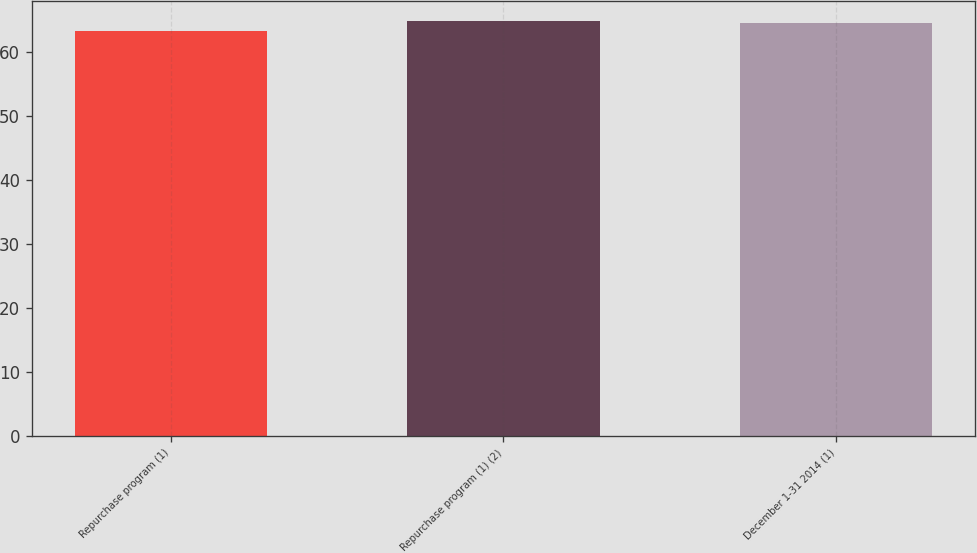<chart> <loc_0><loc_0><loc_500><loc_500><bar_chart><fcel>Repurchase program (1)<fcel>Repurchase program (1) (2)<fcel>December 1-31 2014 (1)<nl><fcel>63.22<fcel>64.76<fcel>64.43<nl></chart> 